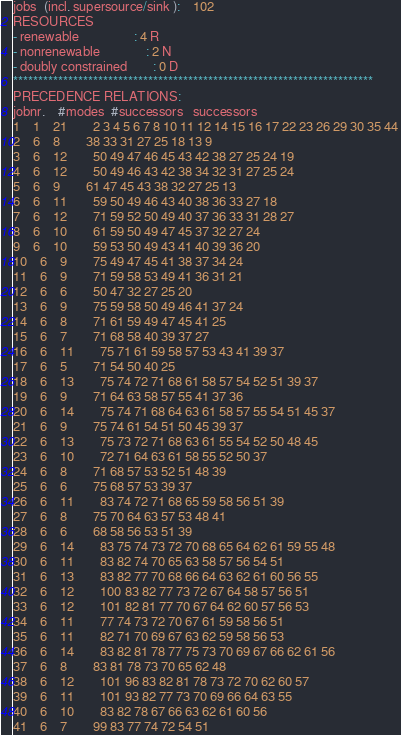Convert code to text. <code><loc_0><loc_0><loc_500><loc_500><_ObjectiveC_>jobs  (incl. supersource/sink ):	102
RESOURCES
- renewable                 : 4 R
- nonrenewable              : 2 N
- doubly constrained        : 0 D
************************************************************************
PRECEDENCE RELATIONS:
jobnr.    #modes  #successors   successors
1	1	21		2 3 4 5 6 7 8 10 11 12 14 15 16 17 22 23 26 29 30 35 44 
2	6	8		38 33 31 27 25 18 13 9 
3	6	12		50 49 47 46 45 43 42 38 27 25 24 19 
4	6	12		50 49 46 43 42 38 34 32 31 27 25 24 
5	6	9		61 47 45 43 38 32 27 25 13 
6	6	11		59 50 49 46 43 40 38 36 33 27 18 
7	6	12		71 59 52 50 49 40 37 36 33 31 28 27 
8	6	10		61 59 50 49 47 45 37 32 27 24 
9	6	10		59 53 50 49 43 41 40 39 36 20 
10	6	9		75 49 47 45 41 38 37 34 24 
11	6	9		71 59 58 53 49 41 36 31 21 
12	6	6		50 47 32 27 25 20 
13	6	9		75 59 58 50 49 46 41 37 24 
14	6	8		71 61 59 49 47 45 41 25 
15	6	7		71 68 58 40 39 37 27 
16	6	11		75 71 61 59 58 57 53 43 41 39 37 
17	6	5		71 54 50 40 25 
18	6	13		75 74 72 71 68 61 58 57 54 52 51 39 37 
19	6	9		71 64 63 58 57 55 41 37 36 
20	6	14		75 74 71 68 64 63 61 58 57 55 54 51 45 37 
21	6	9		75 74 61 54 51 50 45 39 37 
22	6	13		75 73 72 71 68 63 61 55 54 52 50 48 45 
23	6	10		72 71 64 63 61 58 55 52 50 37 
24	6	8		71 68 57 53 52 51 48 39 
25	6	6		75 68 57 53 39 37 
26	6	11		83 74 72 71 68 65 59 58 56 51 39 
27	6	8		75 70 64 63 57 53 48 41 
28	6	6		68 58 56 53 51 39 
29	6	14		83 75 74 73 72 70 68 65 64 62 61 59 55 48 
30	6	11		83 82 74 70 65 63 58 57 56 54 51 
31	6	13		83 82 77 70 68 66 64 63 62 61 60 56 55 
32	6	12		100 83 82 77 73 72 67 64 58 57 56 51 
33	6	12		101 82 81 77 70 67 64 62 60 57 56 53 
34	6	11		77 74 73 72 70 67 61 59 58 56 51 
35	6	11		82 71 70 69 67 63 62 59 58 56 53 
36	6	14		83 82 81 78 77 75 73 70 69 67 66 62 61 56 
37	6	8		83 81 78 73 70 65 62 48 
38	6	12		101 96 83 82 81 78 73 72 70 62 60 57 
39	6	11		101 93 82 77 73 70 69 66 64 63 55 
40	6	10		83 82 78 67 66 63 62 61 60 56 
41	6	7		99 83 77 74 72 54 51 </code> 